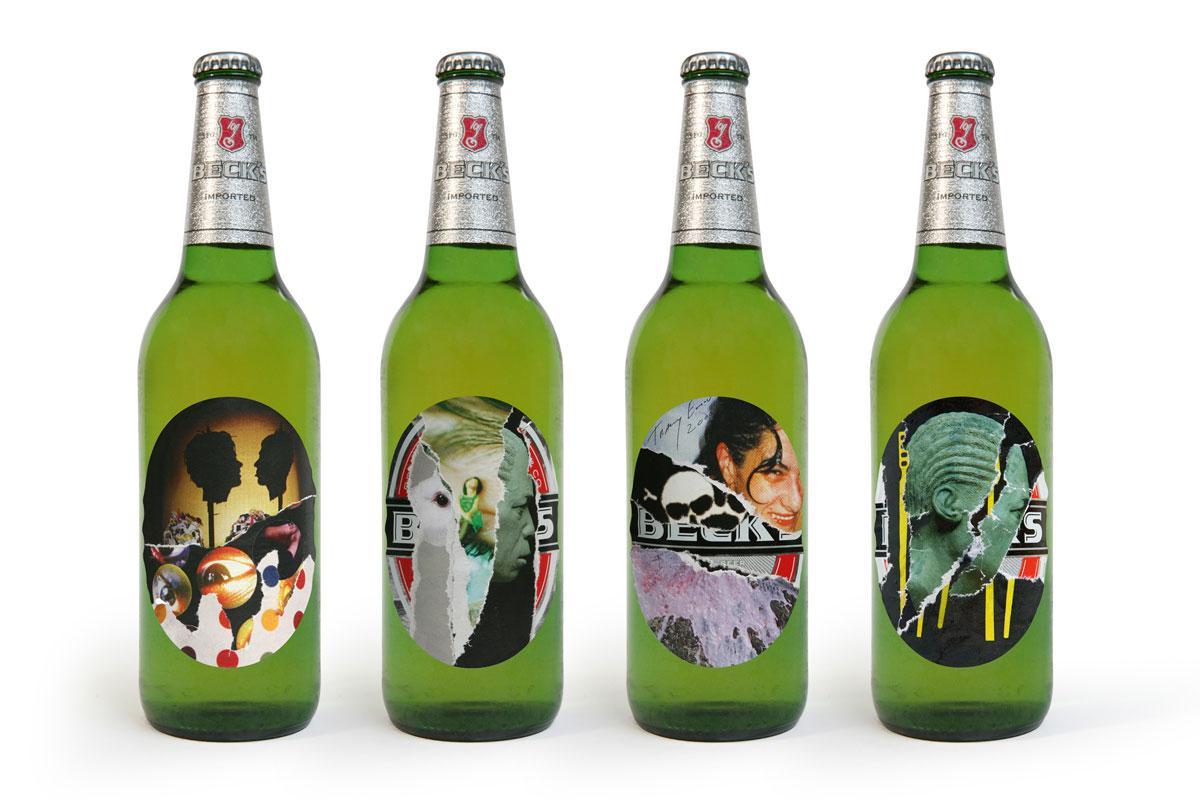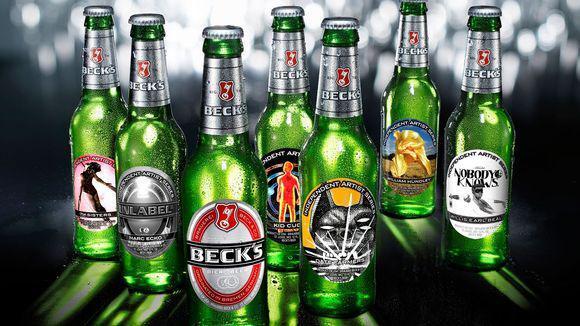The first image is the image on the left, the second image is the image on the right. For the images displayed, is the sentence "Some of the beer is served in a glass, and some is still in bottles." factually correct? Answer yes or no. No. The first image is the image on the left, the second image is the image on the right. Examine the images to the left and right. Is the description "Four or fewer beer bottles are visible." accurate? Answer yes or no. No. 